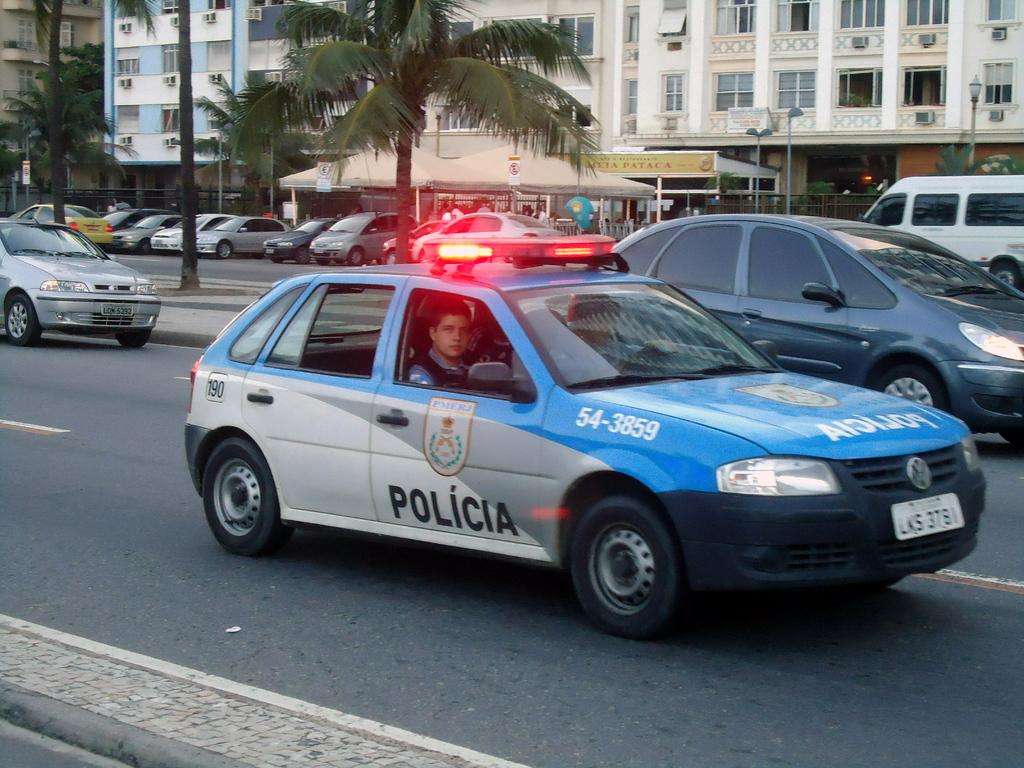What can be seen on the road in the image? There are vehicles on the road in the image. What type of vegetation is present beside the road? There are trees beside the road in the image. Are there any vehicles that are not moving in the image? Yes, there are vehicles parked in the image. What can be seen in the background of the image? There are two buildings in the background of the image. What type of hair can be seen on the vehicles in the image? There is no hair present on the vehicles in the image. What type of mass is being transported by the vehicles in the image? The image does not provide information about the cargo or mass being transported by the vehicles. 